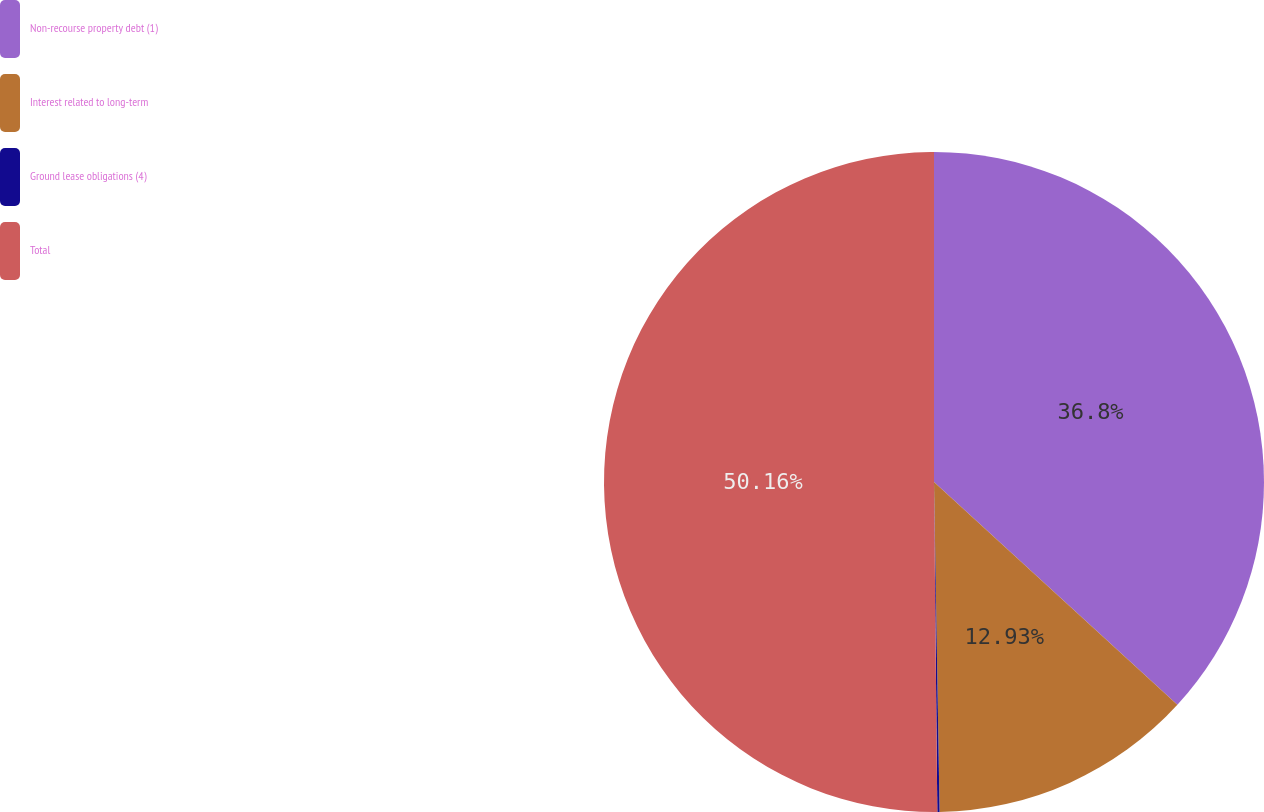Convert chart to OTSL. <chart><loc_0><loc_0><loc_500><loc_500><pie_chart><fcel>Non-recourse property debt (1)<fcel>Interest related to long-term<fcel>Ground lease obligations (4)<fcel>Total<nl><fcel>36.8%<fcel>12.93%<fcel>0.11%<fcel>50.16%<nl></chart> 